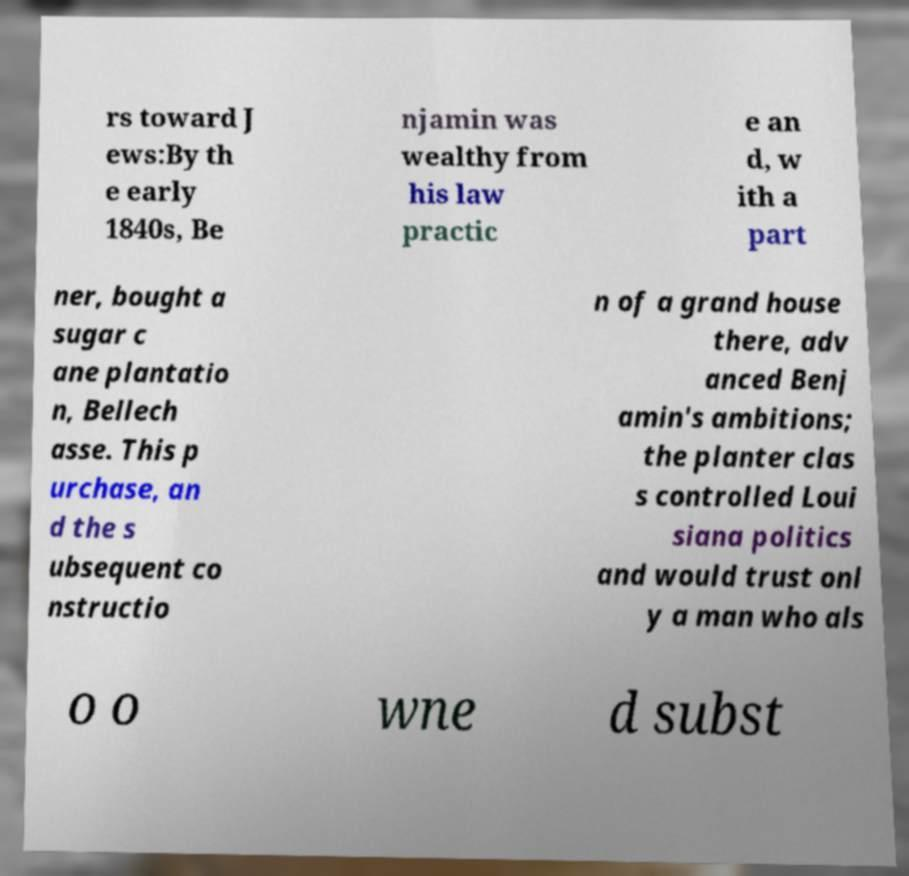What messages or text are displayed in this image? I need them in a readable, typed format. rs toward J ews:By th e early 1840s, Be njamin was wealthy from his law practic e an d, w ith a part ner, bought a sugar c ane plantatio n, Bellech asse. This p urchase, an d the s ubsequent co nstructio n of a grand house there, adv anced Benj amin's ambitions; the planter clas s controlled Loui siana politics and would trust onl y a man who als o o wne d subst 